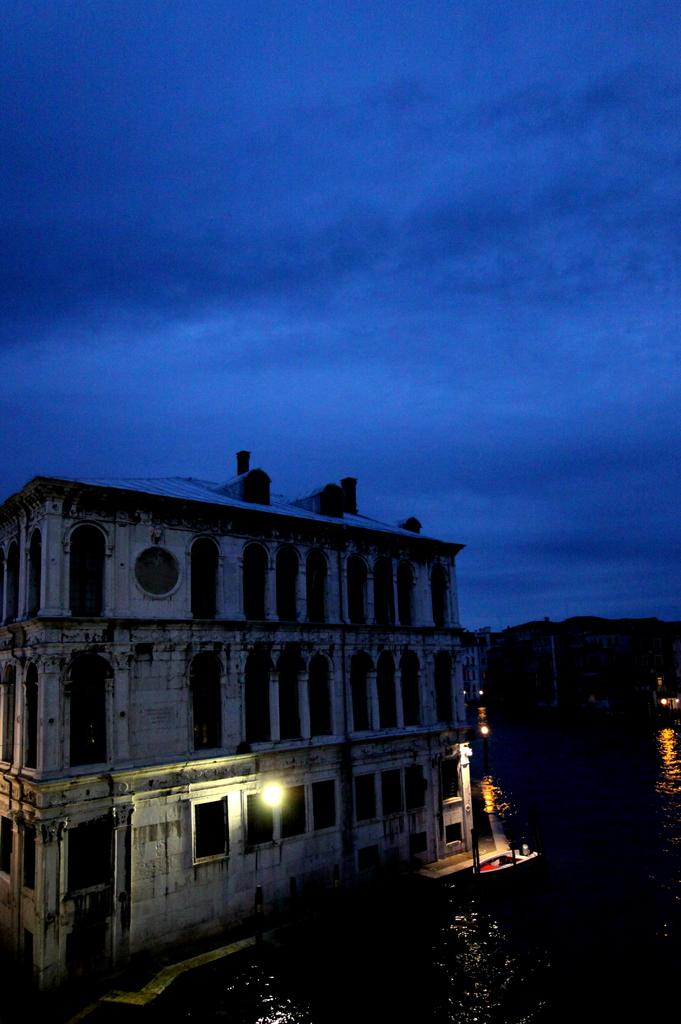What type of structure is present in the image? There is a building in the image. What else can be seen in the image besides the building? There are poles, lights, water, objects on the right side, and the sky visible in the image. What might the poles be used for? The poles might be used to support the lights or other structures. Can you describe the water visible in the image? The water is visible, but its specific location or characteristics are not mentioned in the facts. What type of feather can be seen in the stomach of the person in the image? There is no person or feather present in the image. 